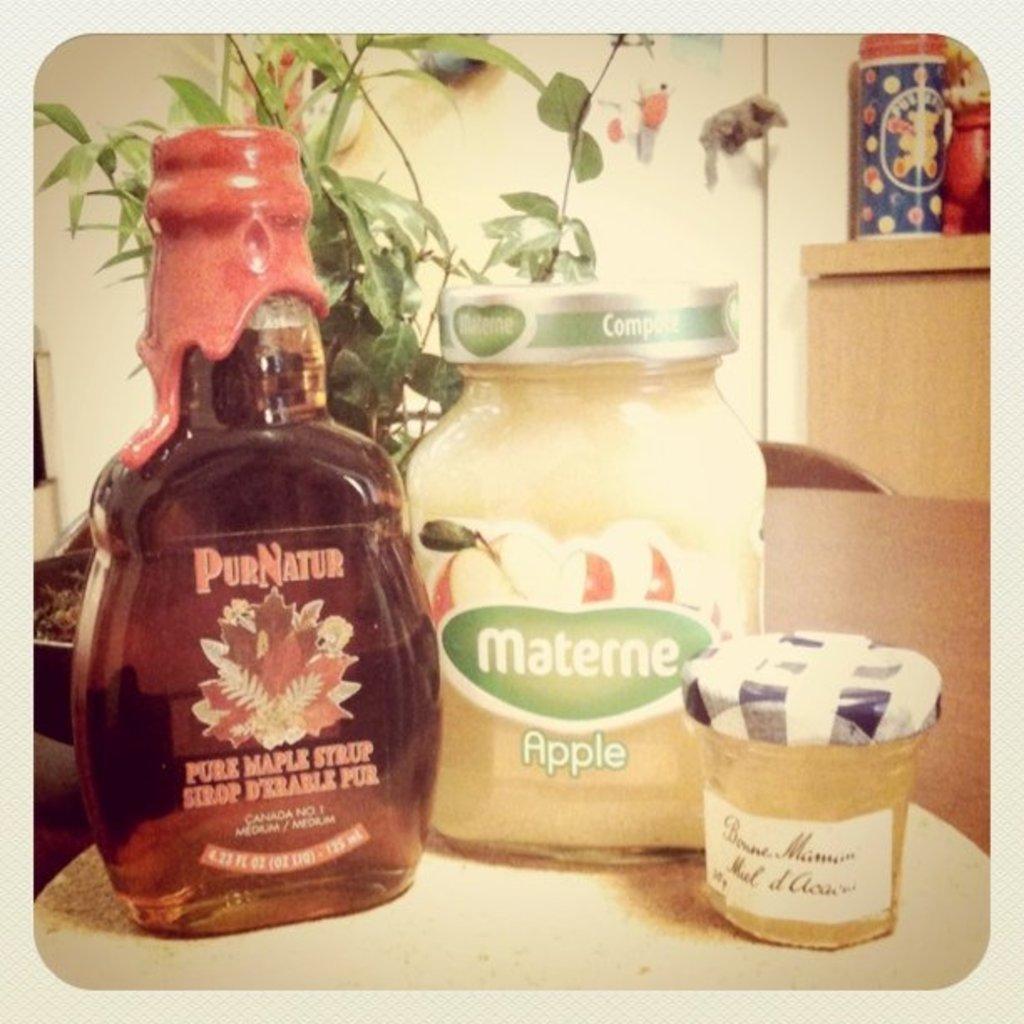What is the brand name of the maple syrup?
Ensure brevity in your answer.  Purnatur. What flavor is the white jar?
Provide a succinct answer. Apple. 